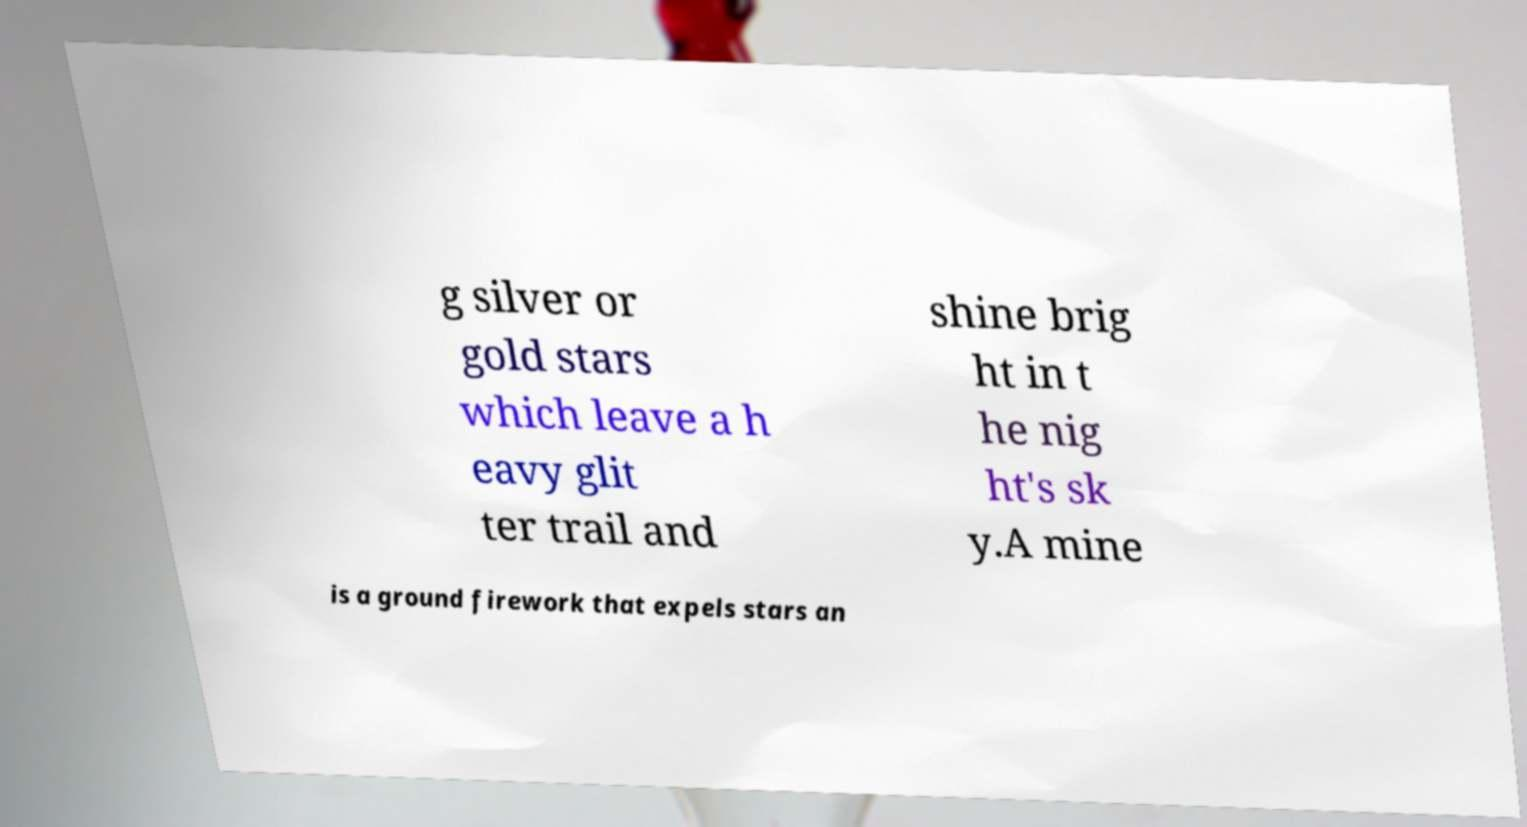There's text embedded in this image that I need extracted. Can you transcribe it verbatim? g silver or gold stars which leave a h eavy glit ter trail and shine brig ht in t he nig ht's sk y.A mine is a ground firework that expels stars an 